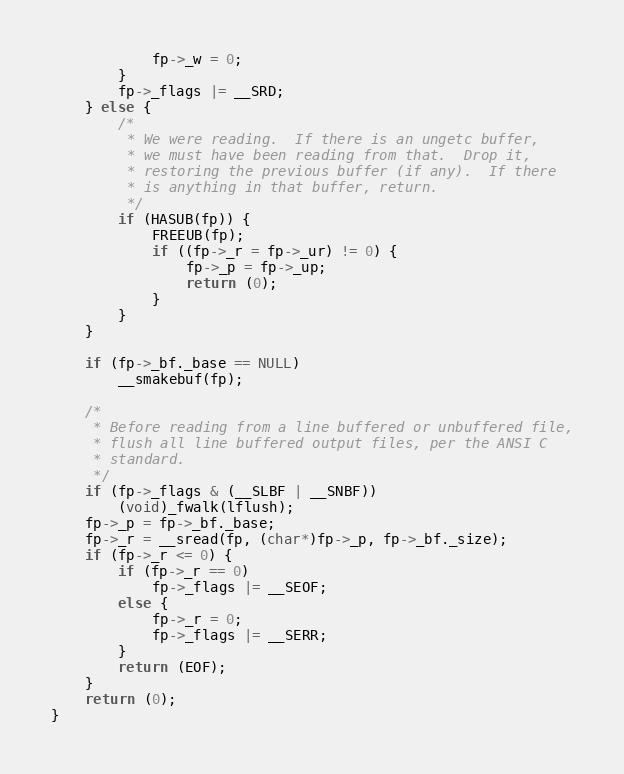Convert code to text. <code><loc_0><loc_0><loc_500><loc_500><_C_>            fp->_w = 0;
        }
        fp->_flags |= __SRD;
    } else {
        /*
         * We were reading.  If there is an ungetc buffer,
         * we must have been reading from that.  Drop it,
         * restoring the previous buffer (if any).  If there
         * is anything in that buffer, return.
         */
        if (HASUB(fp)) {
            FREEUB(fp);
            if ((fp->_r = fp->_ur) != 0) {
                fp->_p = fp->_up;
                return (0);
            }
        }
    }

    if (fp->_bf._base == NULL)
        __smakebuf(fp);

    /*
     * Before reading from a line buffered or unbuffered file,
     * flush all line buffered output files, per the ANSI C
     * standard.
     */
    if (fp->_flags & (__SLBF | __SNBF))
        (void)_fwalk(lflush);
    fp->_p = fp->_bf._base;
    fp->_r = __sread(fp, (char*)fp->_p, fp->_bf._size);
    if (fp->_r <= 0) {
        if (fp->_r == 0)
            fp->_flags |= __SEOF;
        else {
            fp->_r = 0;
            fp->_flags |= __SERR;
        }
        return (EOF);
    }
    return (0);
}
</code> 